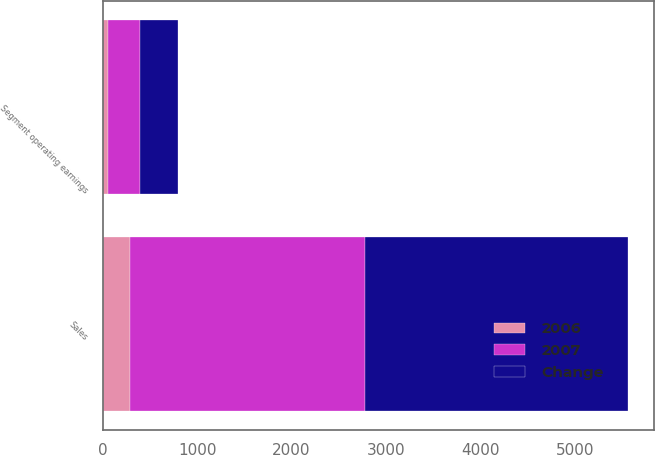Convert chart. <chart><loc_0><loc_0><loc_500><loc_500><stacked_bar_chart><ecel><fcel>Sales<fcel>Segment operating earnings<nl><fcel>Change<fcel>2782.6<fcel>397<nl><fcel>2007<fcel>2497.2<fcel>339.9<nl><fcel>2006<fcel>285.4<fcel>57.1<nl></chart> 